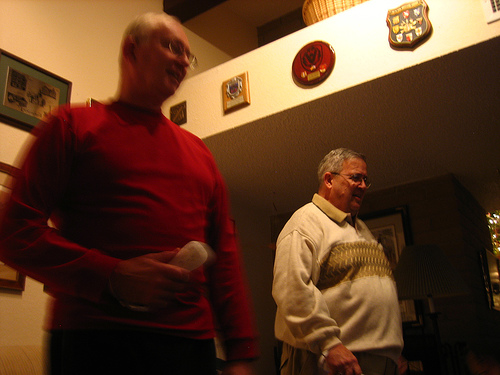What kind of device is the man holding? The man in the foreground is holding a remote control, suggesting he may be operating a television or another electronic device out of view. 